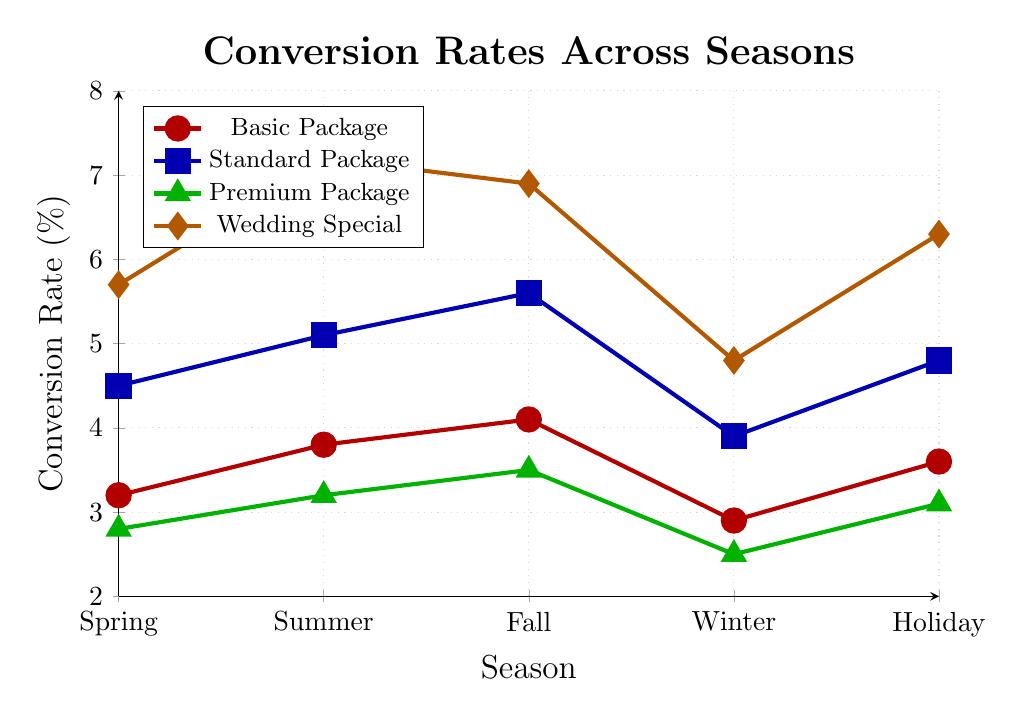What's the highest conversion rate seen in the data and for which package and season? The highest conversion rate in the chart is 7.2%. It is represented by the orange line, corresponding to the Wedding Special package during the Summer season.
Answer: 7.2%, Wedding Special, Summer Which season has the lowest conversion rate for the Premium Package? The green line signifies the Premium Package. The lowest point on this line is at Winter, where the rate is 2.5%.
Answer: Winter By how much did the conversion rate for the Basic Package change from Spring to Summer? The Basic Package is represented by the red line. The conversion rate in Spring is 3.2% and in Summer is 3.8%. The change is calculated as 3.8% - 3.2% = 0.6%.
Answer: 0.6% Compare the Standard Package’s conversion rates between Fall and Holiday Season. Which season had a higher rate and by how much? The blue line signifies the Standard Package. For Fall, the rate is 5.6%, and for the Holiday Season, it is 4.8%. The difference is 5.6% - 4.8% = 0.8%. Fall had a higher rate by 0.8%.
Answer: Fall, 0.8% Which package shows the most significant increase in conversion rates from Winter to Holiday Season? We calculate the differences: 
- Basic Package: 3.6% - 2.9% = 0.7%
- Standard Package: 4.8% - 3.9% = 0.9%
- Premium Package: 3.1% - 2.5% = 0.6%
- Wedding Special: 6.3% - 4.8% = 1.5%
The Wedding Special package shows the most significant increase of 1.5%.
Answer: Wedding Special What is the average conversion rate for the Wedding Special package across all seasons? The Wedding Special conversion rates are: 5.7%, 7.2%, 6.9%, 4.8%, and 6.3%. Their average is (5.7 + 7.2 + 6.9 + 4.8 + 6.3) / 5 = 6.18%.
Answer: 6.18% Is there any season where all four packages have conversion rates above 3%? We compare the rates for each season:
- Spring: Basic (3.2%), Standard (4.5%), Premium (2.8%), Wedding (5.7%) — No
- Summer: Basic (3.8%), Standard (5.1%), Premium (3.2%), Wedding (7.2%) — Yes
- Fall: Basic (4.1%), Standard (5.6%), Premium (3.5%), Wedding (6.9%) — Yes
- Winter: Basic (2.9%), Standard (3.9%), Premium (2.5%), Wedding (4.8%) — No
- Holiday: Basic (3.6%), Standard (4.8%), Premium (3.1%), Wedding (6.3%) — Yes
The Summer, Fall, and Holiday seasons see all packages above 3%.
Answer: Yes, in Summer, Fall, and Holiday seasons 